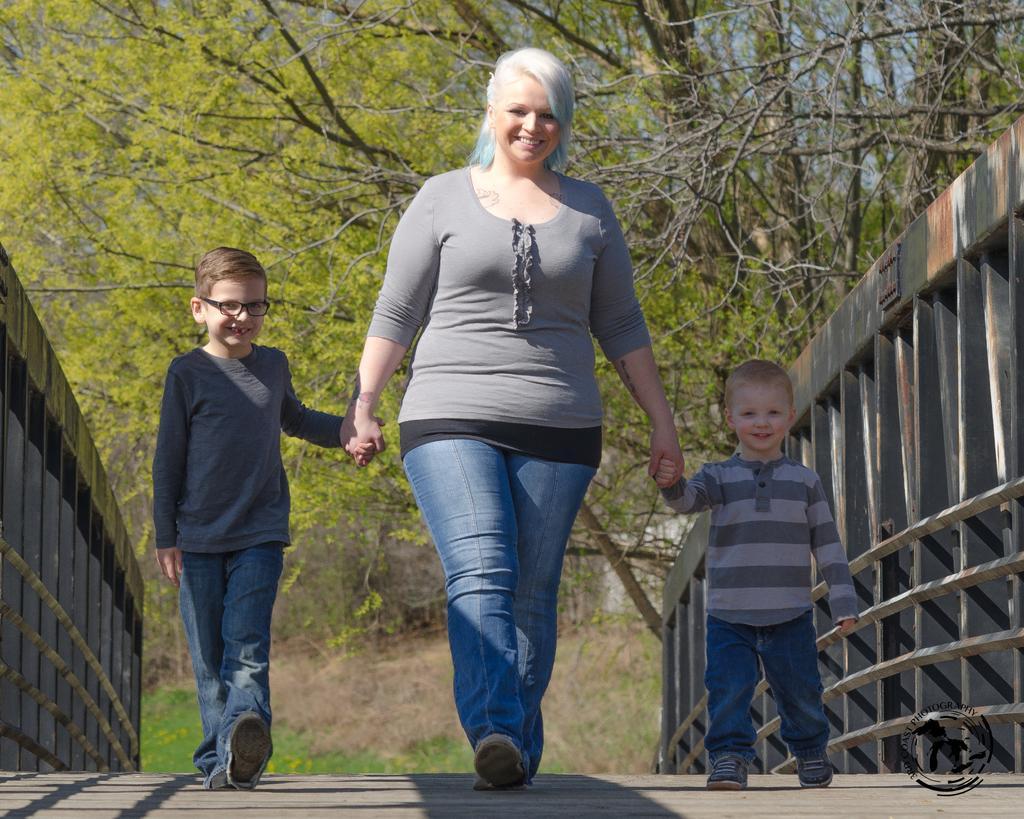How would you summarize this image in a sentence or two? In this image we can see a woman and two children are walking on the wooden bridge. In the background, we can see the trees. 